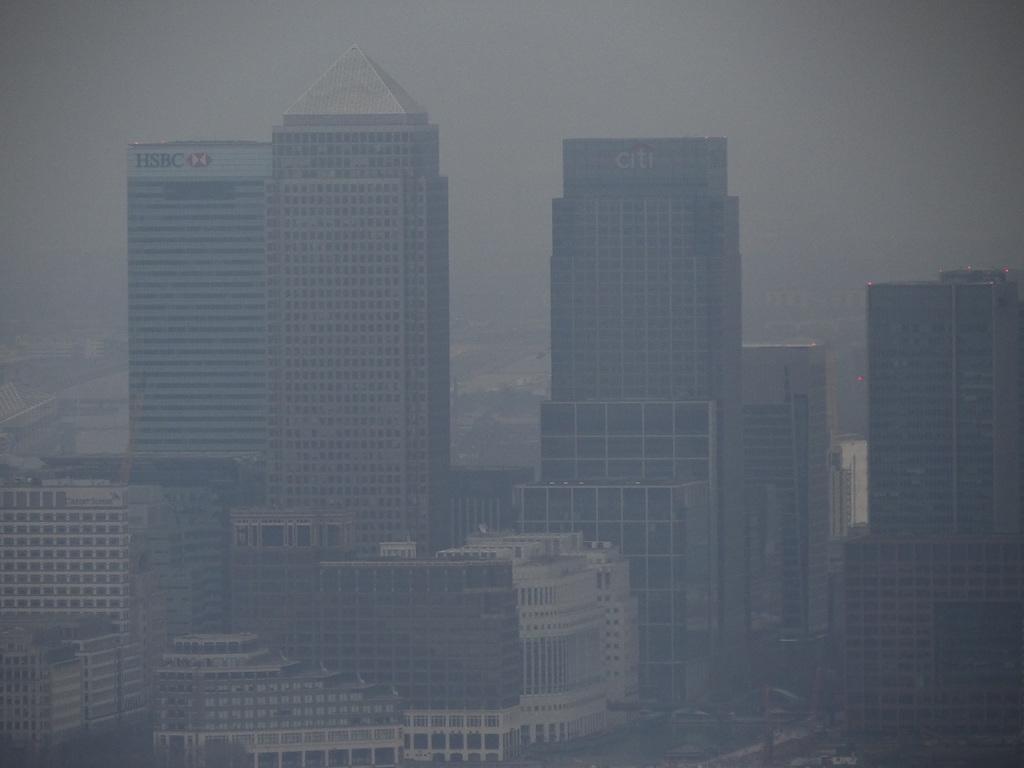Please provide a concise description of this image. In the image there are many buildings and most of them are some organisations. 